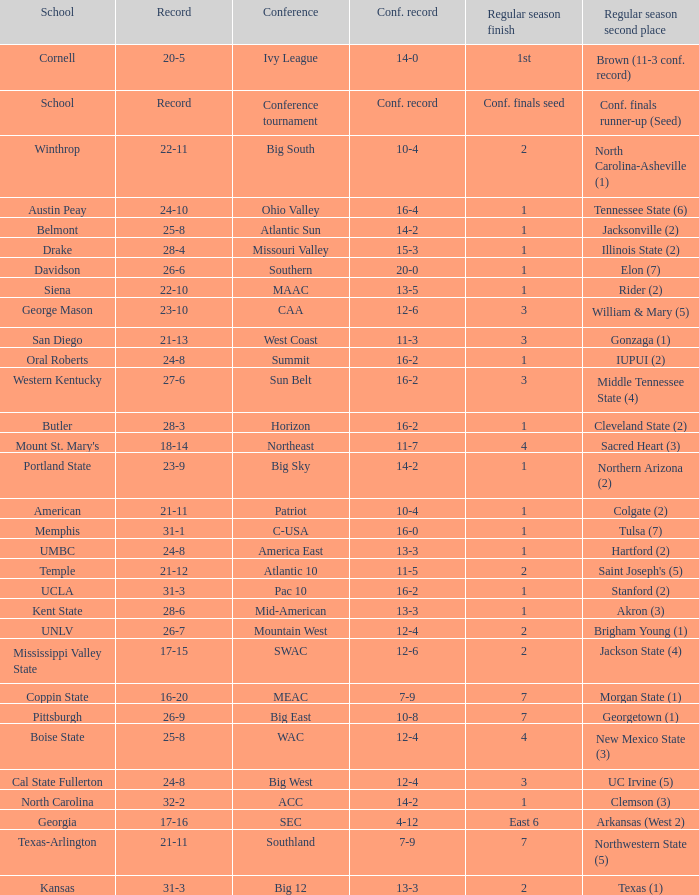What was the cumulative record of oral roberts university? 24-8. Would you mind parsing the complete table? {'header': ['School', 'Record', 'Conference', 'Conf. record', 'Regular season finish', 'Regular season second place'], 'rows': [['Cornell', '20-5', 'Ivy League', '14-0', '1st', 'Brown (11-3 conf. record)'], ['School', 'Record', 'Conference tournament', 'Conf. record', 'Conf. finals seed', 'Conf. finals runner-up (Seed)'], ['Winthrop', '22-11', 'Big South', '10-4', '2', 'North Carolina-Asheville (1)'], ['Austin Peay', '24-10', 'Ohio Valley', '16-4', '1', 'Tennessee State (6)'], ['Belmont', '25-8', 'Atlantic Sun', '14-2', '1', 'Jacksonville (2)'], ['Drake', '28-4', 'Missouri Valley', '15-3', '1', 'Illinois State (2)'], ['Davidson', '26-6', 'Southern', '20-0', '1', 'Elon (7)'], ['Siena', '22-10', 'MAAC', '13-5', '1', 'Rider (2)'], ['George Mason', '23-10', 'CAA', '12-6', '3', 'William & Mary (5)'], ['San Diego', '21-13', 'West Coast', '11-3', '3', 'Gonzaga (1)'], ['Oral Roberts', '24-8', 'Summit', '16-2', '1', 'IUPUI (2)'], ['Western Kentucky', '27-6', 'Sun Belt', '16-2', '3', 'Middle Tennessee State (4)'], ['Butler', '28-3', 'Horizon', '16-2', '1', 'Cleveland State (2)'], ["Mount St. Mary's", '18-14', 'Northeast', '11-7', '4', 'Sacred Heart (3)'], ['Portland State', '23-9', 'Big Sky', '14-2', '1', 'Northern Arizona (2)'], ['American', '21-11', 'Patriot', '10-4', '1', 'Colgate (2)'], ['Memphis', '31-1', 'C-USA', '16-0', '1', 'Tulsa (7)'], ['UMBC', '24-8', 'America East', '13-3', '1', 'Hartford (2)'], ['Temple', '21-12', 'Atlantic 10', '11-5', '2', "Saint Joseph's (5)"], ['UCLA', '31-3', 'Pac 10', '16-2', '1', 'Stanford (2)'], ['Kent State', '28-6', 'Mid-American', '13-3', '1', 'Akron (3)'], ['UNLV', '26-7', 'Mountain West', '12-4', '2', 'Brigham Young (1)'], ['Mississippi Valley State', '17-15', 'SWAC', '12-6', '2', 'Jackson State (4)'], ['Coppin State', '16-20', 'MEAC', '7-9', '7', 'Morgan State (1)'], ['Pittsburgh', '26-9', 'Big East', '10-8', '7', 'Georgetown (1)'], ['Boise State', '25-8', 'WAC', '12-4', '4', 'New Mexico State (3)'], ['Cal State Fullerton', '24-8', 'Big West', '12-4', '3', 'UC Irvine (5)'], ['North Carolina', '32-2', 'ACC', '14-2', '1', 'Clemson (3)'], ['Georgia', '17-16', 'SEC', '4-12', 'East 6', 'Arkansas (West 2)'], ['Texas-Arlington', '21-11', 'Southland', '7-9', '7', 'Northwestern State (5)'], ['Kansas', '31-3', 'Big 12', '13-3', '2', 'Texas (1)']]} 